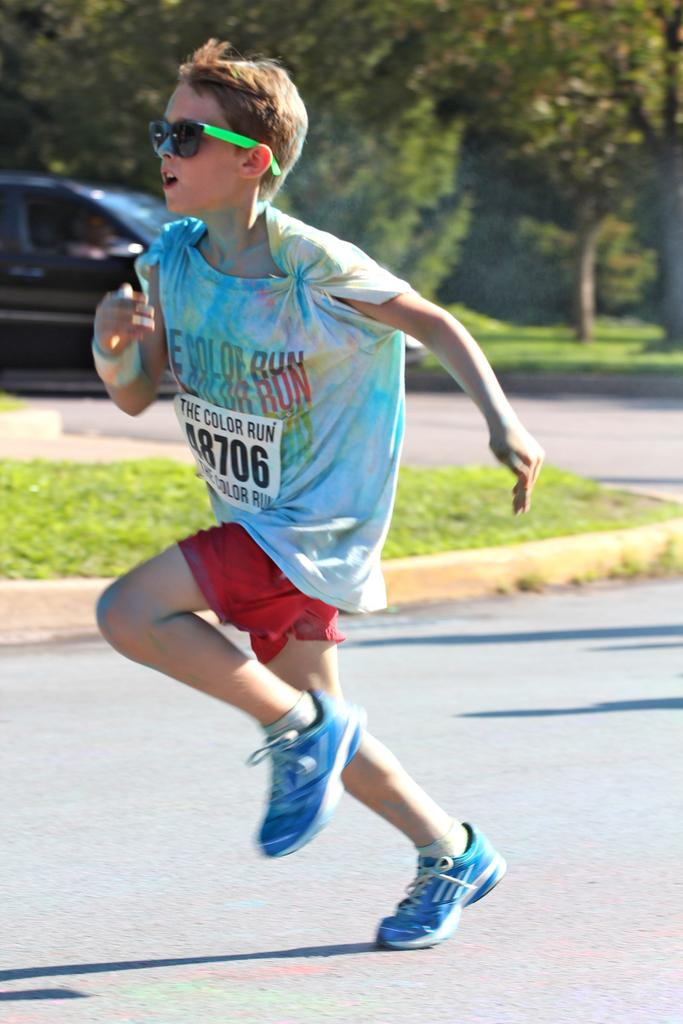Who is the main subject in the image? There is a boy in the image. What is the boy doing in the image? The boy is running on the road. What can be seen in the background of the image? There are trees, a vehicle, and grass in the background of the image. What type of engine can be heard in the image? There is no engine or sound present in the image, as it is a still photograph. 